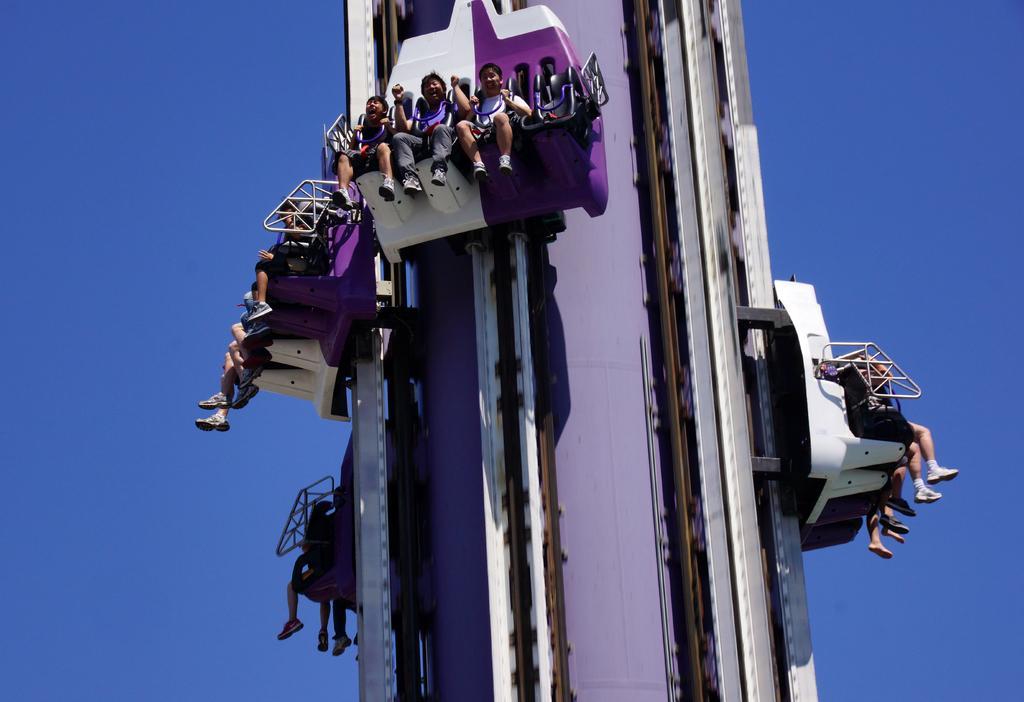Can you describe this image briefly? In this image I can see group of people sitting on the ride. In the background I can see the sky in blue color. 